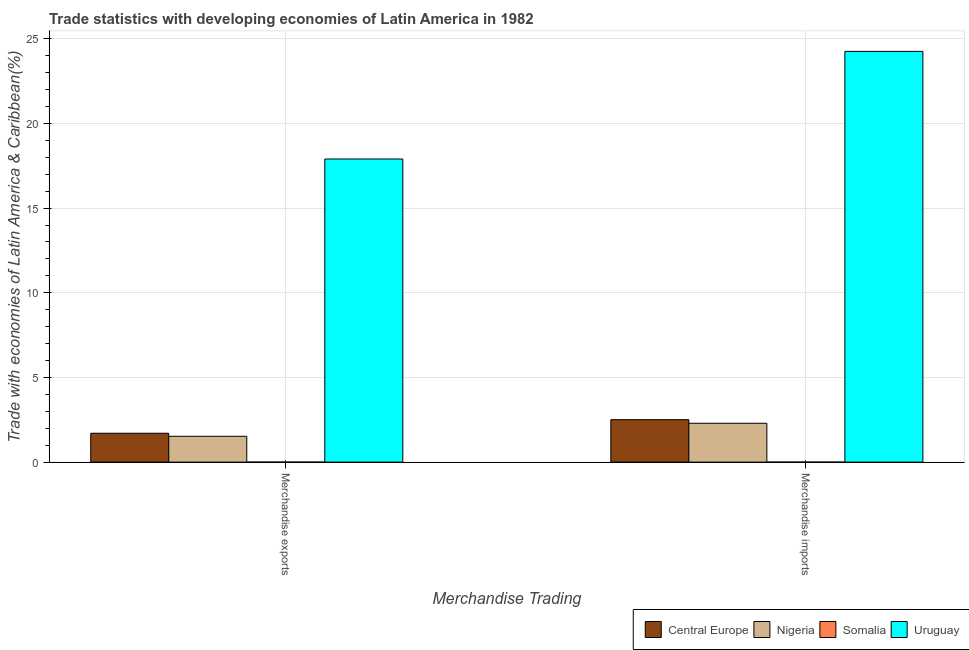How many groups of bars are there?
Your answer should be very brief. 2. Are the number of bars per tick equal to the number of legend labels?
Your answer should be very brief. Yes. Are the number of bars on each tick of the X-axis equal?
Your answer should be very brief. Yes. How many bars are there on the 1st tick from the right?
Your response must be concise. 4. What is the merchandise exports in Uruguay?
Your answer should be compact. 17.9. Across all countries, what is the maximum merchandise exports?
Offer a very short reply. 17.9. Across all countries, what is the minimum merchandise imports?
Give a very brief answer. 0. In which country was the merchandise imports maximum?
Your response must be concise. Uruguay. In which country was the merchandise exports minimum?
Provide a short and direct response. Somalia. What is the total merchandise imports in the graph?
Provide a short and direct response. 29.06. What is the difference between the merchandise imports in Nigeria and that in Uruguay?
Ensure brevity in your answer.  -21.96. What is the difference between the merchandise exports in Somalia and the merchandise imports in Uruguay?
Your answer should be compact. -24.26. What is the average merchandise exports per country?
Your answer should be very brief. 5.28. What is the difference between the merchandise imports and merchandise exports in Uruguay?
Your answer should be very brief. 6.36. In how many countries, is the merchandise imports greater than 2 %?
Your answer should be very brief. 3. What is the ratio of the merchandise imports in Somalia to that in Central Europe?
Ensure brevity in your answer.  0. What does the 1st bar from the left in Merchandise imports represents?
Your answer should be compact. Central Europe. What does the 3rd bar from the right in Merchandise exports represents?
Your answer should be compact. Nigeria. How many countries are there in the graph?
Your answer should be very brief. 4. Where does the legend appear in the graph?
Ensure brevity in your answer.  Bottom right. What is the title of the graph?
Offer a very short reply. Trade statistics with developing economies of Latin America in 1982. Does "Uganda" appear as one of the legend labels in the graph?
Provide a succinct answer. No. What is the label or title of the X-axis?
Provide a short and direct response. Merchandise Trading. What is the label or title of the Y-axis?
Offer a very short reply. Trade with economies of Latin America & Caribbean(%). What is the Trade with economies of Latin America & Caribbean(%) of Central Europe in Merchandise exports?
Make the answer very short. 1.71. What is the Trade with economies of Latin America & Caribbean(%) in Nigeria in Merchandise exports?
Make the answer very short. 1.53. What is the Trade with economies of Latin America & Caribbean(%) of Somalia in Merchandise exports?
Offer a very short reply. 0. What is the Trade with economies of Latin America & Caribbean(%) of Uruguay in Merchandise exports?
Offer a terse response. 17.9. What is the Trade with economies of Latin America & Caribbean(%) of Central Europe in Merchandise imports?
Keep it short and to the point. 2.51. What is the Trade with economies of Latin America & Caribbean(%) of Nigeria in Merchandise imports?
Your response must be concise. 2.3. What is the Trade with economies of Latin America & Caribbean(%) in Somalia in Merchandise imports?
Your response must be concise. 0. What is the Trade with economies of Latin America & Caribbean(%) in Uruguay in Merchandise imports?
Provide a succinct answer. 24.26. Across all Merchandise Trading, what is the maximum Trade with economies of Latin America & Caribbean(%) in Central Europe?
Offer a terse response. 2.51. Across all Merchandise Trading, what is the maximum Trade with economies of Latin America & Caribbean(%) of Nigeria?
Provide a succinct answer. 2.3. Across all Merchandise Trading, what is the maximum Trade with economies of Latin America & Caribbean(%) in Somalia?
Your answer should be compact. 0. Across all Merchandise Trading, what is the maximum Trade with economies of Latin America & Caribbean(%) in Uruguay?
Provide a short and direct response. 24.26. Across all Merchandise Trading, what is the minimum Trade with economies of Latin America & Caribbean(%) in Central Europe?
Provide a succinct answer. 1.71. Across all Merchandise Trading, what is the minimum Trade with economies of Latin America & Caribbean(%) of Nigeria?
Offer a very short reply. 1.53. Across all Merchandise Trading, what is the minimum Trade with economies of Latin America & Caribbean(%) in Somalia?
Make the answer very short. 0. Across all Merchandise Trading, what is the minimum Trade with economies of Latin America & Caribbean(%) of Uruguay?
Give a very brief answer. 17.9. What is the total Trade with economies of Latin America & Caribbean(%) of Central Europe in the graph?
Your response must be concise. 4.21. What is the total Trade with economies of Latin America & Caribbean(%) of Nigeria in the graph?
Keep it short and to the point. 3.82. What is the total Trade with economies of Latin America & Caribbean(%) of Somalia in the graph?
Your response must be concise. 0. What is the total Trade with economies of Latin America & Caribbean(%) of Uruguay in the graph?
Give a very brief answer. 42.15. What is the difference between the Trade with economies of Latin America & Caribbean(%) in Central Europe in Merchandise exports and that in Merchandise imports?
Ensure brevity in your answer.  -0.8. What is the difference between the Trade with economies of Latin America & Caribbean(%) of Nigeria in Merchandise exports and that in Merchandise imports?
Provide a succinct answer. -0.77. What is the difference between the Trade with economies of Latin America & Caribbean(%) in Somalia in Merchandise exports and that in Merchandise imports?
Offer a very short reply. -0. What is the difference between the Trade with economies of Latin America & Caribbean(%) in Uruguay in Merchandise exports and that in Merchandise imports?
Keep it short and to the point. -6.36. What is the difference between the Trade with economies of Latin America & Caribbean(%) of Central Europe in Merchandise exports and the Trade with economies of Latin America & Caribbean(%) of Nigeria in Merchandise imports?
Make the answer very short. -0.59. What is the difference between the Trade with economies of Latin America & Caribbean(%) of Central Europe in Merchandise exports and the Trade with economies of Latin America & Caribbean(%) of Somalia in Merchandise imports?
Provide a succinct answer. 1.7. What is the difference between the Trade with economies of Latin America & Caribbean(%) of Central Europe in Merchandise exports and the Trade with economies of Latin America & Caribbean(%) of Uruguay in Merchandise imports?
Offer a terse response. -22.55. What is the difference between the Trade with economies of Latin America & Caribbean(%) in Nigeria in Merchandise exports and the Trade with economies of Latin America & Caribbean(%) in Somalia in Merchandise imports?
Your response must be concise. 1.52. What is the difference between the Trade with economies of Latin America & Caribbean(%) of Nigeria in Merchandise exports and the Trade with economies of Latin America & Caribbean(%) of Uruguay in Merchandise imports?
Offer a terse response. -22.73. What is the difference between the Trade with economies of Latin America & Caribbean(%) of Somalia in Merchandise exports and the Trade with economies of Latin America & Caribbean(%) of Uruguay in Merchandise imports?
Your response must be concise. -24.26. What is the average Trade with economies of Latin America & Caribbean(%) of Central Europe per Merchandise Trading?
Keep it short and to the point. 2.11. What is the average Trade with economies of Latin America & Caribbean(%) of Nigeria per Merchandise Trading?
Your answer should be compact. 1.91. What is the average Trade with economies of Latin America & Caribbean(%) in Somalia per Merchandise Trading?
Offer a very short reply. 0. What is the average Trade with economies of Latin America & Caribbean(%) in Uruguay per Merchandise Trading?
Provide a succinct answer. 21.08. What is the difference between the Trade with economies of Latin America & Caribbean(%) of Central Europe and Trade with economies of Latin America & Caribbean(%) of Nigeria in Merchandise exports?
Ensure brevity in your answer.  0.18. What is the difference between the Trade with economies of Latin America & Caribbean(%) in Central Europe and Trade with economies of Latin America & Caribbean(%) in Somalia in Merchandise exports?
Provide a short and direct response. 1.7. What is the difference between the Trade with economies of Latin America & Caribbean(%) of Central Europe and Trade with economies of Latin America & Caribbean(%) of Uruguay in Merchandise exports?
Give a very brief answer. -16.19. What is the difference between the Trade with economies of Latin America & Caribbean(%) in Nigeria and Trade with economies of Latin America & Caribbean(%) in Somalia in Merchandise exports?
Provide a short and direct response. 1.52. What is the difference between the Trade with economies of Latin America & Caribbean(%) in Nigeria and Trade with economies of Latin America & Caribbean(%) in Uruguay in Merchandise exports?
Provide a short and direct response. -16.37. What is the difference between the Trade with economies of Latin America & Caribbean(%) in Somalia and Trade with economies of Latin America & Caribbean(%) in Uruguay in Merchandise exports?
Ensure brevity in your answer.  -17.9. What is the difference between the Trade with economies of Latin America & Caribbean(%) in Central Europe and Trade with economies of Latin America & Caribbean(%) in Nigeria in Merchandise imports?
Ensure brevity in your answer.  0.21. What is the difference between the Trade with economies of Latin America & Caribbean(%) of Central Europe and Trade with economies of Latin America & Caribbean(%) of Somalia in Merchandise imports?
Your response must be concise. 2.51. What is the difference between the Trade with economies of Latin America & Caribbean(%) of Central Europe and Trade with economies of Latin America & Caribbean(%) of Uruguay in Merchandise imports?
Offer a very short reply. -21.75. What is the difference between the Trade with economies of Latin America & Caribbean(%) of Nigeria and Trade with economies of Latin America & Caribbean(%) of Somalia in Merchandise imports?
Offer a terse response. 2.29. What is the difference between the Trade with economies of Latin America & Caribbean(%) in Nigeria and Trade with economies of Latin America & Caribbean(%) in Uruguay in Merchandise imports?
Give a very brief answer. -21.96. What is the difference between the Trade with economies of Latin America & Caribbean(%) of Somalia and Trade with economies of Latin America & Caribbean(%) of Uruguay in Merchandise imports?
Your response must be concise. -24.25. What is the ratio of the Trade with economies of Latin America & Caribbean(%) of Central Europe in Merchandise exports to that in Merchandise imports?
Keep it short and to the point. 0.68. What is the ratio of the Trade with economies of Latin America & Caribbean(%) in Nigeria in Merchandise exports to that in Merchandise imports?
Offer a terse response. 0.66. What is the ratio of the Trade with economies of Latin America & Caribbean(%) of Somalia in Merchandise exports to that in Merchandise imports?
Your response must be concise. 0.41. What is the ratio of the Trade with economies of Latin America & Caribbean(%) of Uruguay in Merchandise exports to that in Merchandise imports?
Provide a succinct answer. 0.74. What is the difference between the highest and the second highest Trade with economies of Latin America & Caribbean(%) of Central Europe?
Provide a short and direct response. 0.8. What is the difference between the highest and the second highest Trade with economies of Latin America & Caribbean(%) of Nigeria?
Provide a short and direct response. 0.77. What is the difference between the highest and the second highest Trade with economies of Latin America & Caribbean(%) of Somalia?
Offer a very short reply. 0. What is the difference between the highest and the second highest Trade with economies of Latin America & Caribbean(%) of Uruguay?
Your response must be concise. 6.36. What is the difference between the highest and the lowest Trade with economies of Latin America & Caribbean(%) of Central Europe?
Provide a short and direct response. 0.8. What is the difference between the highest and the lowest Trade with economies of Latin America & Caribbean(%) of Nigeria?
Offer a terse response. 0.77. What is the difference between the highest and the lowest Trade with economies of Latin America & Caribbean(%) of Somalia?
Provide a succinct answer. 0. What is the difference between the highest and the lowest Trade with economies of Latin America & Caribbean(%) in Uruguay?
Your response must be concise. 6.36. 